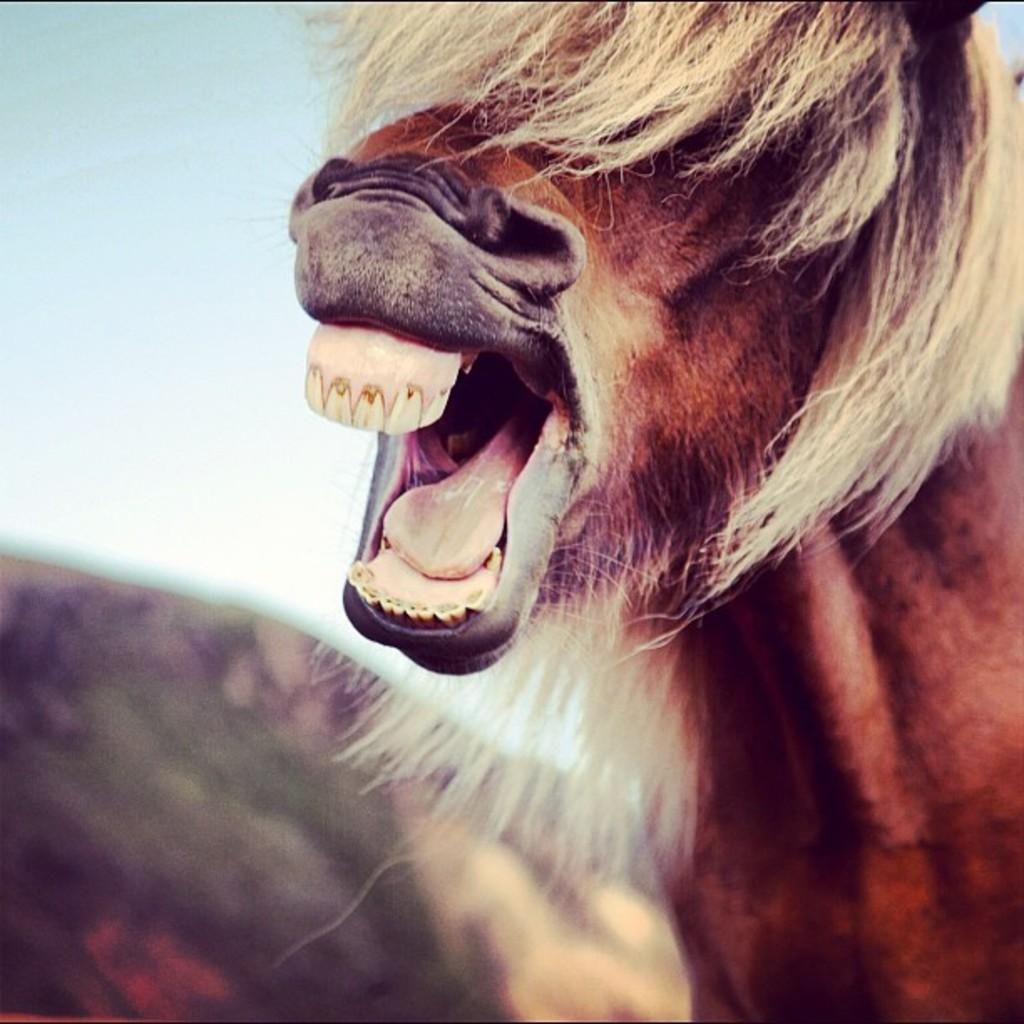What type of animal can be seen in the image? There is a brown color animal in the image. What is the position of the animal in the image? The animal is standing in the image. On which side of the image is the animal located? The animal is on the right side of the image. How would you describe the background of the image? The background of the image is blurred. Are there any visible cobwebs in the image? There is no mention of cobwebs in the provided facts, and therefore we cannot determine if any are present in the image. 